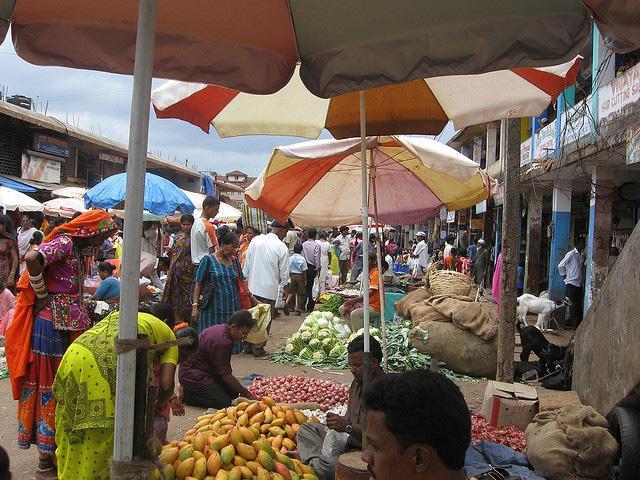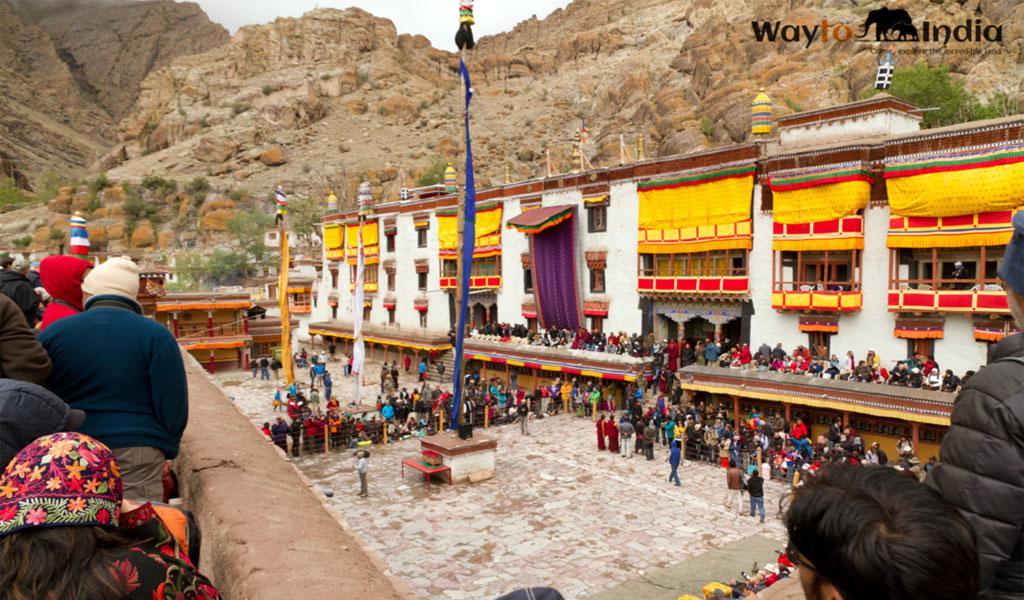The first image is the image on the left, the second image is the image on the right. Evaluate the accuracy of this statement regarding the images: "The left and right image contains the same number of monasteries.". Is it true? Answer yes or no. No. The first image is the image on the left, the second image is the image on the right. Given the left and right images, does the statement "An image shows the exterior of a temple with bold, decorative symbols repeating across a white banner running the length of the building." hold true? Answer yes or no. No. 